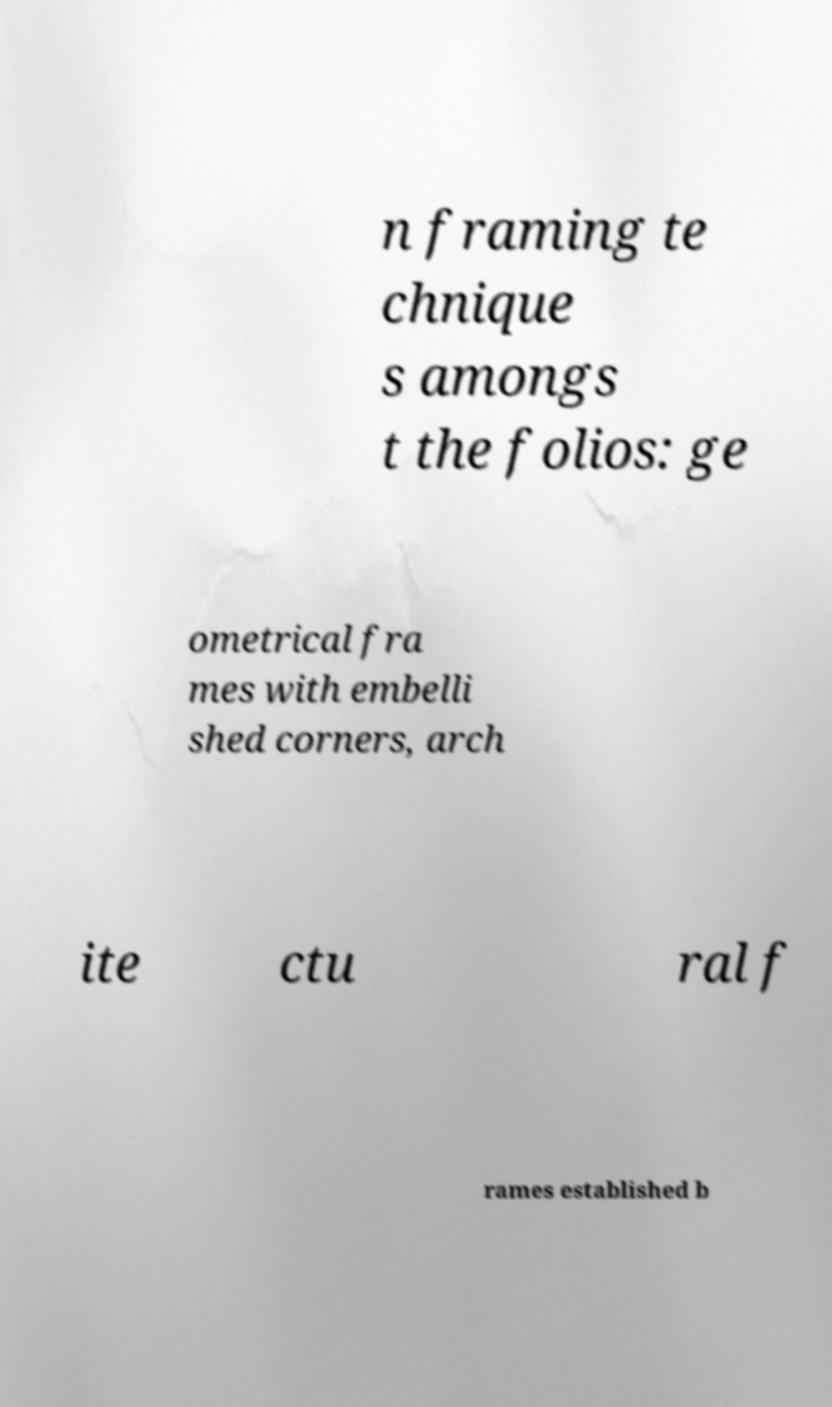For documentation purposes, I need the text within this image transcribed. Could you provide that? n framing te chnique s amongs t the folios: ge ometrical fra mes with embelli shed corners, arch ite ctu ral f rames established b 